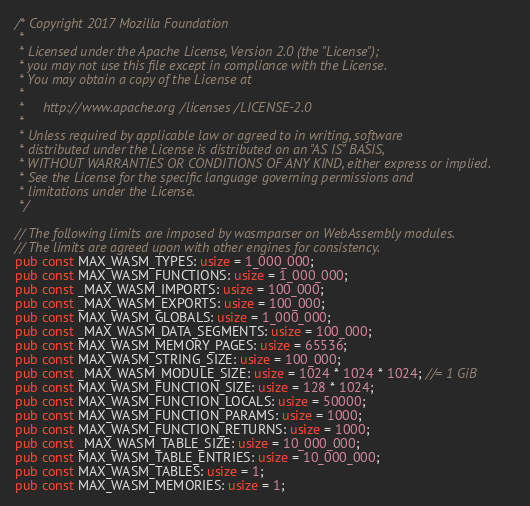<code> <loc_0><loc_0><loc_500><loc_500><_Rust_>/* Copyright 2017 Mozilla Foundation
 *
 * Licensed under the Apache License, Version 2.0 (the "License");
 * you may not use this file except in compliance with the License.
 * You may obtain a copy of the License at
 *
 *     http://www.apache.org/licenses/LICENSE-2.0
 *
 * Unless required by applicable law or agreed to in writing, software
 * distributed under the License is distributed on an "AS IS" BASIS,
 * WITHOUT WARRANTIES OR CONDITIONS OF ANY KIND, either express or implied.
 * See the License for the specific language governing permissions and
 * limitations under the License.
 */

// The following limits are imposed by wasmparser on WebAssembly modules.
// The limits are agreed upon with other engines for consistency.
pub const MAX_WASM_TYPES: usize = 1_000_000;
pub const MAX_WASM_FUNCTIONS: usize = 1_000_000;
pub const _MAX_WASM_IMPORTS: usize = 100_000;
pub const _MAX_WASM_EXPORTS: usize = 100_000;
pub const MAX_WASM_GLOBALS: usize = 1_000_000;
pub const _MAX_WASM_DATA_SEGMENTS: usize = 100_000;
pub const MAX_WASM_MEMORY_PAGES: usize = 65536;
pub const MAX_WASM_STRING_SIZE: usize = 100_000;
pub const _MAX_WASM_MODULE_SIZE: usize = 1024 * 1024 * 1024; //= 1 GiB
pub const MAX_WASM_FUNCTION_SIZE: usize = 128 * 1024;
pub const MAX_WASM_FUNCTION_LOCALS: usize = 50000;
pub const MAX_WASM_FUNCTION_PARAMS: usize = 1000;
pub const MAX_WASM_FUNCTION_RETURNS: usize = 1000;
pub const _MAX_WASM_TABLE_SIZE: usize = 10_000_000;
pub const MAX_WASM_TABLE_ENTRIES: usize = 10_000_000;
pub const MAX_WASM_TABLES: usize = 1;
pub const MAX_WASM_MEMORIES: usize = 1;
</code> 